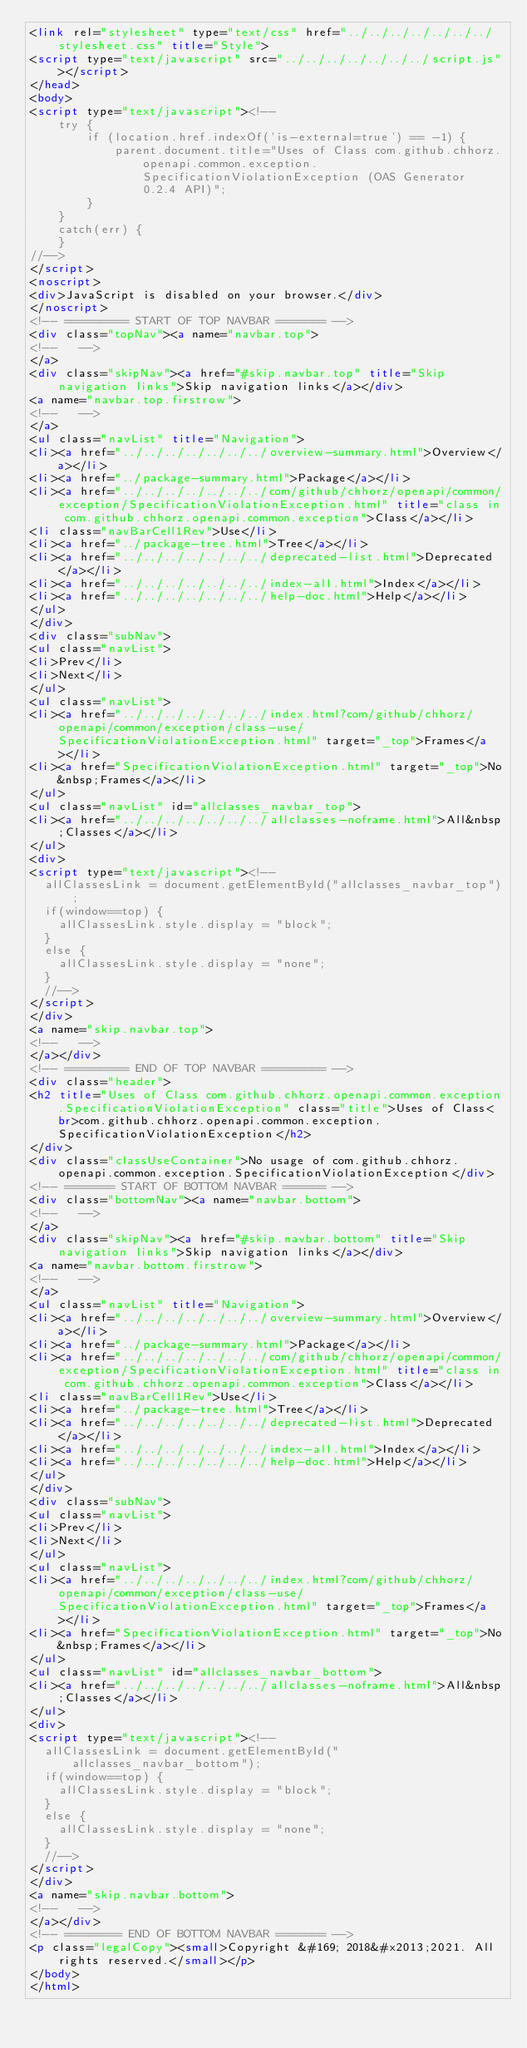<code> <loc_0><loc_0><loc_500><loc_500><_HTML_><link rel="stylesheet" type="text/css" href="../../../../../../../stylesheet.css" title="Style">
<script type="text/javascript" src="../../../../../../../script.js"></script>
</head>
<body>
<script type="text/javascript"><!--
    try {
        if (location.href.indexOf('is-external=true') == -1) {
            parent.document.title="Uses of Class com.github.chhorz.openapi.common.exception.SpecificationViolationException (OAS Generator 0.2.4 API)";
        }
    }
    catch(err) {
    }
//-->
</script>
<noscript>
<div>JavaScript is disabled on your browser.</div>
</noscript>
<!-- ========= START OF TOP NAVBAR ======= -->
<div class="topNav"><a name="navbar.top">
<!--   -->
</a>
<div class="skipNav"><a href="#skip.navbar.top" title="Skip navigation links">Skip navigation links</a></div>
<a name="navbar.top.firstrow">
<!--   -->
</a>
<ul class="navList" title="Navigation">
<li><a href="../../../../../../../overview-summary.html">Overview</a></li>
<li><a href="../package-summary.html">Package</a></li>
<li><a href="../../../../../../../com/github/chhorz/openapi/common/exception/SpecificationViolationException.html" title="class in com.github.chhorz.openapi.common.exception">Class</a></li>
<li class="navBarCell1Rev">Use</li>
<li><a href="../package-tree.html">Tree</a></li>
<li><a href="../../../../../../../deprecated-list.html">Deprecated</a></li>
<li><a href="../../../../../../../index-all.html">Index</a></li>
<li><a href="../../../../../../../help-doc.html">Help</a></li>
</ul>
</div>
<div class="subNav">
<ul class="navList">
<li>Prev</li>
<li>Next</li>
</ul>
<ul class="navList">
<li><a href="../../../../../../../index.html?com/github/chhorz/openapi/common/exception/class-use/SpecificationViolationException.html" target="_top">Frames</a></li>
<li><a href="SpecificationViolationException.html" target="_top">No&nbsp;Frames</a></li>
</ul>
<ul class="navList" id="allclasses_navbar_top">
<li><a href="../../../../../../../allclasses-noframe.html">All&nbsp;Classes</a></li>
</ul>
<div>
<script type="text/javascript"><!--
  allClassesLink = document.getElementById("allclasses_navbar_top");
  if(window==top) {
    allClassesLink.style.display = "block";
  }
  else {
    allClassesLink.style.display = "none";
  }
  //-->
</script>
</div>
<a name="skip.navbar.top">
<!--   -->
</a></div>
<!-- ========= END OF TOP NAVBAR ========= -->
<div class="header">
<h2 title="Uses of Class com.github.chhorz.openapi.common.exception.SpecificationViolationException" class="title">Uses of Class<br>com.github.chhorz.openapi.common.exception.SpecificationViolationException</h2>
</div>
<div class="classUseContainer">No usage of com.github.chhorz.openapi.common.exception.SpecificationViolationException</div>
<!-- ======= START OF BOTTOM NAVBAR ====== -->
<div class="bottomNav"><a name="navbar.bottom">
<!--   -->
</a>
<div class="skipNav"><a href="#skip.navbar.bottom" title="Skip navigation links">Skip navigation links</a></div>
<a name="navbar.bottom.firstrow">
<!--   -->
</a>
<ul class="navList" title="Navigation">
<li><a href="../../../../../../../overview-summary.html">Overview</a></li>
<li><a href="../package-summary.html">Package</a></li>
<li><a href="../../../../../../../com/github/chhorz/openapi/common/exception/SpecificationViolationException.html" title="class in com.github.chhorz.openapi.common.exception">Class</a></li>
<li class="navBarCell1Rev">Use</li>
<li><a href="../package-tree.html">Tree</a></li>
<li><a href="../../../../../../../deprecated-list.html">Deprecated</a></li>
<li><a href="../../../../../../../index-all.html">Index</a></li>
<li><a href="../../../../../../../help-doc.html">Help</a></li>
</ul>
</div>
<div class="subNav">
<ul class="navList">
<li>Prev</li>
<li>Next</li>
</ul>
<ul class="navList">
<li><a href="../../../../../../../index.html?com/github/chhorz/openapi/common/exception/class-use/SpecificationViolationException.html" target="_top">Frames</a></li>
<li><a href="SpecificationViolationException.html" target="_top">No&nbsp;Frames</a></li>
</ul>
<ul class="navList" id="allclasses_navbar_bottom">
<li><a href="../../../../../../../allclasses-noframe.html">All&nbsp;Classes</a></li>
</ul>
<div>
<script type="text/javascript"><!--
  allClassesLink = document.getElementById("allclasses_navbar_bottom");
  if(window==top) {
    allClassesLink.style.display = "block";
  }
  else {
    allClassesLink.style.display = "none";
  }
  //-->
</script>
</div>
<a name="skip.navbar.bottom">
<!--   -->
</a></div>
<!-- ======== END OF BOTTOM NAVBAR ======= -->
<p class="legalCopy"><small>Copyright &#169; 2018&#x2013;2021. All rights reserved.</small></p>
</body>
</html>
</code> 